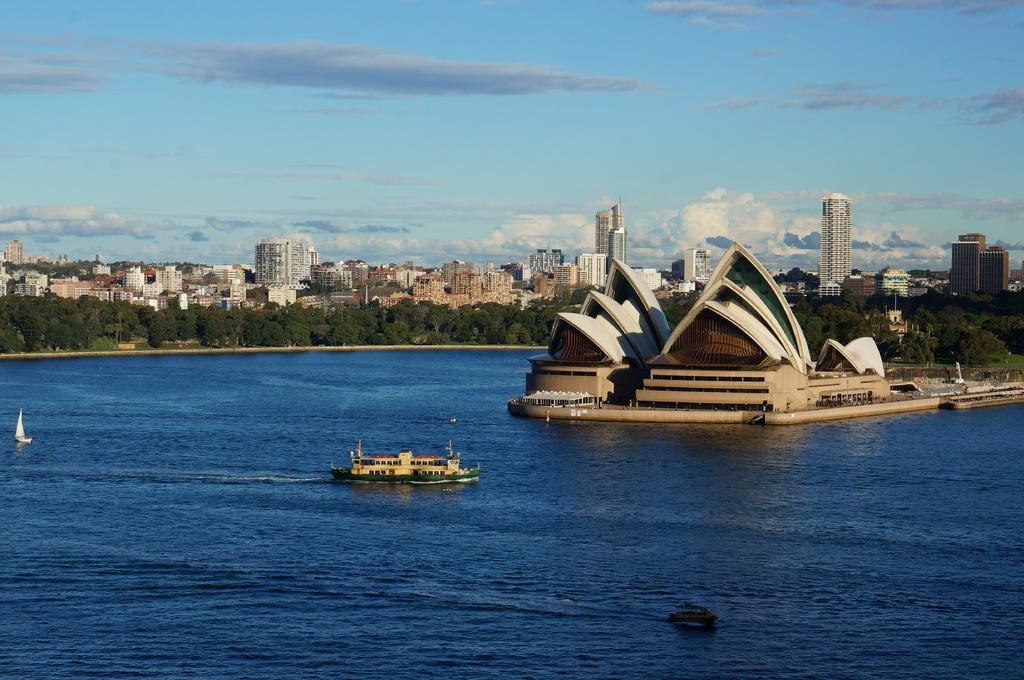What type of structure is located in the water in the image? There is a building in the water in the image. What other watercraft can be seen in the water? There is a ship and boats in the water. What type of vegetation is visible in the image? There are trees visible in the image. What else can be seen on land in the image? There are buildings visible in the image. How would you describe the sky in the image? The sky is blue and cloudy. Can you tell me how many ducks are sitting under the umbrella in the image? There are no ducks or umbrellas present in the image. What is the brother of the building in the water doing in the image? There is no mention of a brother to the building in the water, and no such activity can be observed. 